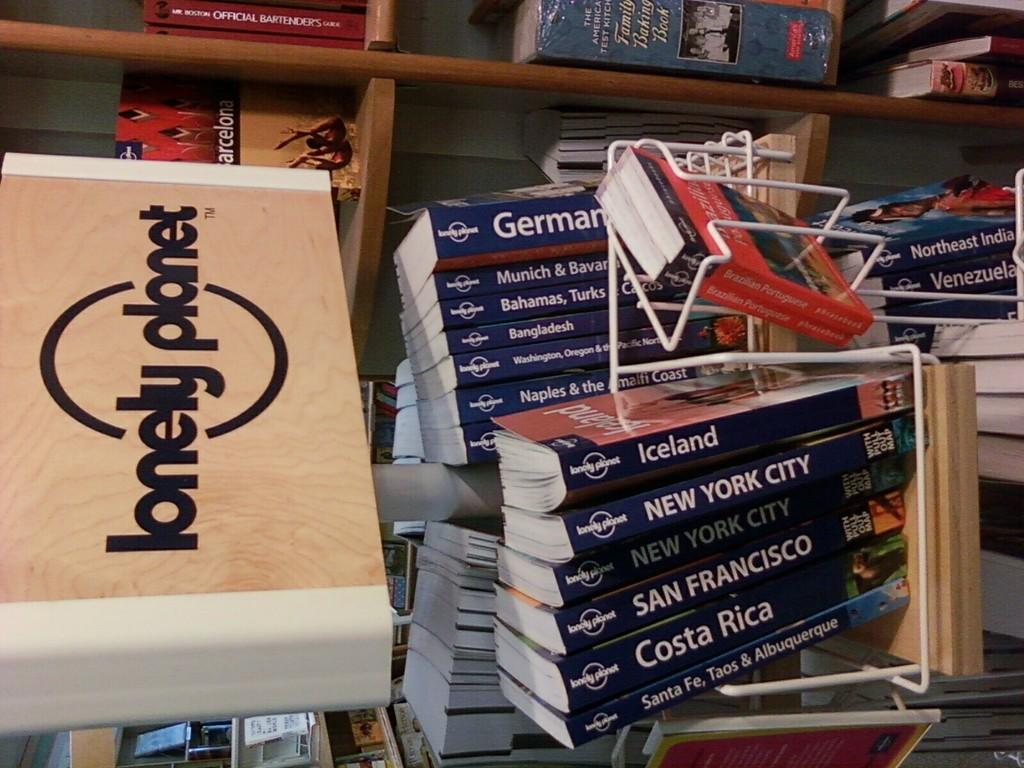<image>
Render a clear and concise summary of the photo. Shelves of new books of cities and a lonely planet brand. 